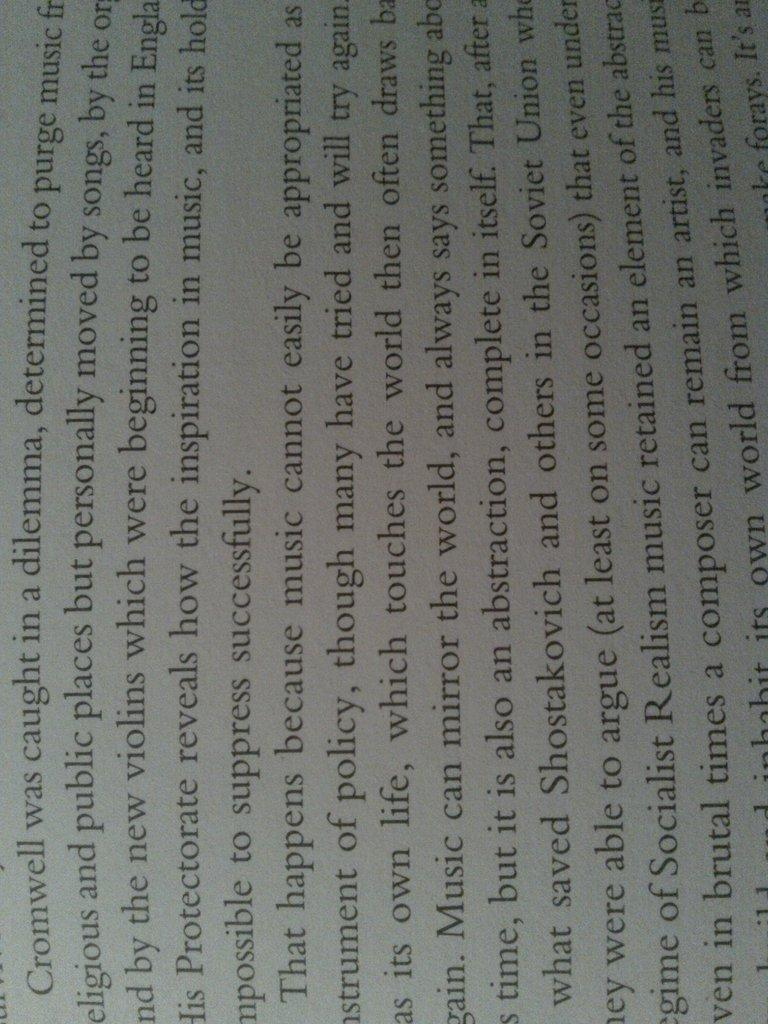<image>
Create a compact narrative representing the image presented. A page from a book describing what Cromwell was up to. 